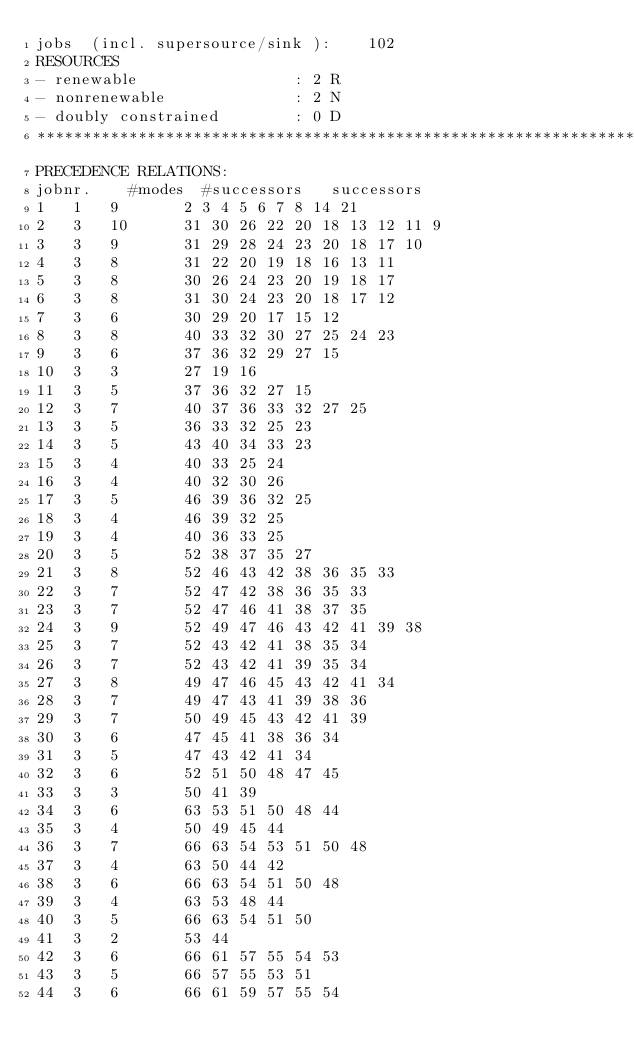Convert code to text. <code><loc_0><loc_0><loc_500><loc_500><_ObjectiveC_>jobs  (incl. supersource/sink ):	102
RESOURCES
- renewable                 : 2 R
- nonrenewable              : 2 N
- doubly constrained        : 0 D
************************************************************************
PRECEDENCE RELATIONS:
jobnr.    #modes  #successors   successors
1	1	9		2 3 4 5 6 7 8 14 21 
2	3	10		31 30 26 22 20 18 13 12 11 9 
3	3	9		31 29 28 24 23 20 18 17 10 
4	3	8		31 22 20 19 18 16 13 11 
5	3	8		30 26 24 23 20 19 18 17 
6	3	8		31 30 24 23 20 18 17 12 
7	3	6		30 29 20 17 15 12 
8	3	8		40 33 32 30 27 25 24 23 
9	3	6		37 36 32 29 27 15 
10	3	3		27 19 16 
11	3	5		37 36 32 27 15 
12	3	7		40 37 36 33 32 27 25 
13	3	5		36 33 32 25 23 
14	3	5		43 40 34 33 23 
15	3	4		40 33 25 24 
16	3	4		40 32 30 26 
17	3	5		46 39 36 32 25 
18	3	4		46 39 32 25 
19	3	4		40 36 33 25 
20	3	5		52 38 37 35 27 
21	3	8		52 46 43 42 38 36 35 33 
22	3	7		52 47 42 38 36 35 33 
23	3	7		52 47 46 41 38 37 35 
24	3	9		52 49 47 46 43 42 41 39 38 
25	3	7		52 43 42 41 38 35 34 
26	3	7		52 43 42 41 39 35 34 
27	3	8		49 47 46 45 43 42 41 34 
28	3	7		49 47 43 41 39 38 36 
29	3	7		50 49 45 43 42 41 39 
30	3	6		47 45 41 38 36 34 
31	3	5		47 43 42 41 34 
32	3	6		52 51 50 48 47 45 
33	3	3		50 41 39 
34	3	6		63 53 51 50 48 44 
35	3	4		50 49 45 44 
36	3	7		66 63 54 53 51 50 48 
37	3	4		63 50 44 42 
38	3	6		66 63 54 51 50 48 
39	3	4		63 53 48 44 
40	3	5		66 63 54 51 50 
41	3	2		53 44 
42	3	6		66 61 57 55 54 53 
43	3	5		66 57 55 53 51 
44	3	6		66 61 59 57 55 54 </code> 